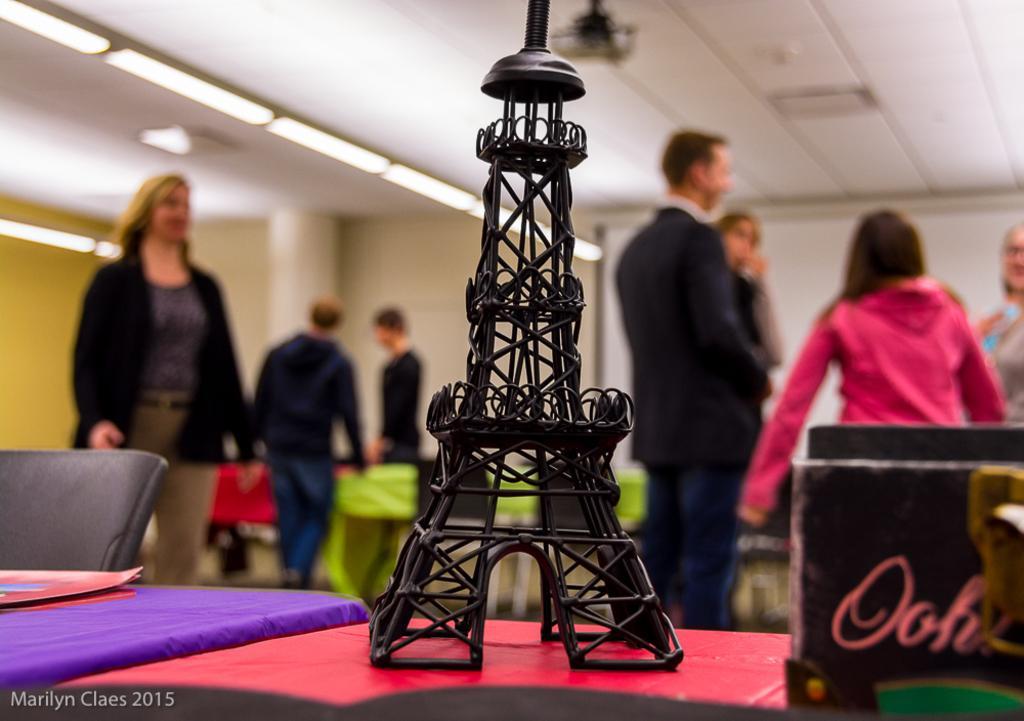Describe this image in one or two sentences. In this image we can see people standing on the floor and tables are placed in front of them. On the tables there are decors, stationary and pen stand. In the background there are ceiling fan and electric lights. 